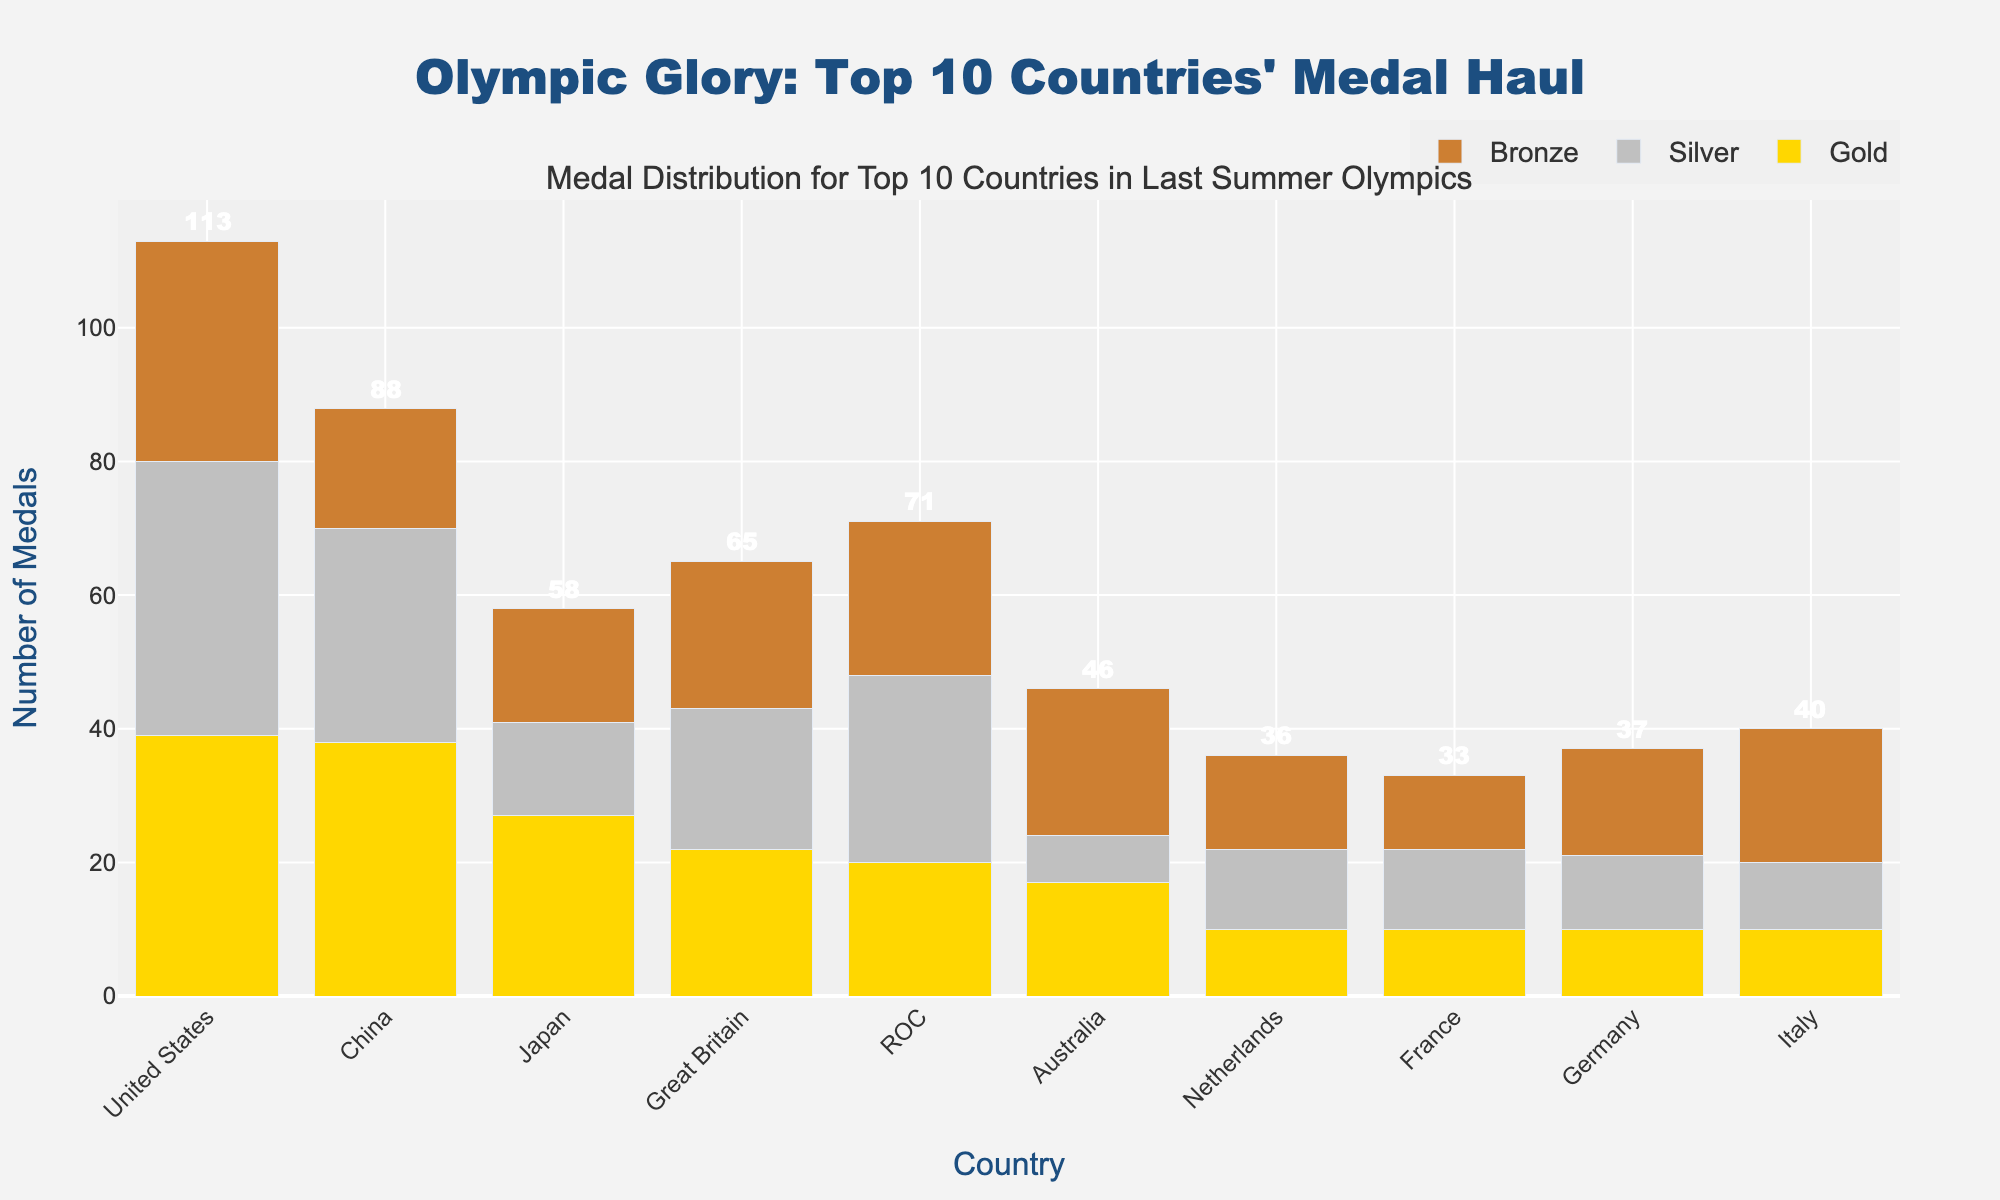Which country won the most gold medals? Look at the heights of the gold-colored bars for each country. The United States has the tallest gold bar representing 39 gold medals, which is the highest of all countries.
Answer: United States How many total medals did China win? Observe the text annotations above the bars representing China's medals. The total number of medals for China is annotated as 88.
Answer: 88 Which country has more silver medals, Great Britain or ROC? Compare the heights of the silver-colored bars for Great Britain and ROC. ROC's silver bar is taller, indicating ROC has more silver medals.
Answer: ROC What is the difference in the number of bronze medals between Germany and Italy? Look at the bronze-colored bars for Germany and Italy. Germany has 16 bronze medals, and Italy has 20. The difference is 20 - 16.
Answer: 4 Which country won the least number of medals overall? Identify the country with the smallest total medal count annotated above the bars. France, with a total of 33 medals, has the least number of medals.
Answer: France What is the combined total number of gold medals won by Australia and Netherlands? Sum the heights of the gold-colored bars for Australia and Netherlands. Australia has 17 gold medals and Netherlands has 10. The combined total is 17 + 10.
Answer: 27 What is the ratio of gold to total medals for Japan? Determine the gold and total medal counts for Japan. Japan has 27 gold medals and 58 total medals. The ratio is 27:58.
Answer: 27:58 How does the total medal count of Great Britain compare to ROC? Compare the total medal annotations for Great Britain and ROC. Great Britain has 65 medals, while ROC has 71. ROC has more medals.
Answer: ROC What percentage of France’s medals are silver? Calculate the percentage of silver medals out of the total medals for France. France has 12 silver medals and a total of 33 medals. The percentage is (12/33) * 100.
Answer: ~36.36% If the total number of medals won by Italy and Germany were combined, what would that total be? Sum the total medals for Italy and Germany. Italy has 40 total medals and Germany has 37. The combined total is 40 + 37.
Answer: 77 